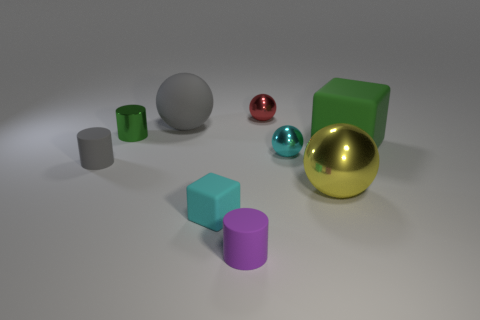Subtract all red metal spheres. How many spheres are left? 3 Add 1 small green metallic objects. How many objects exist? 10 Subtract all green blocks. How many blocks are left? 1 Subtract all cylinders. How many objects are left? 6 Add 5 tiny purple cylinders. How many tiny purple cylinders are left? 6 Add 7 tiny gray matte cylinders. How many tiny gray matte cylinders exist? 8 Subtract 1 cyan cubes. How many objects are left? 8 Subtract 4 spheres. How many spheres are left? 0 Subtract all cyan cylinders. Subtract all purple cubes. How many cylinders are left? 3 Subtract all big matte blocks. Subtract all metallic spheres. How many objects are left? 5 